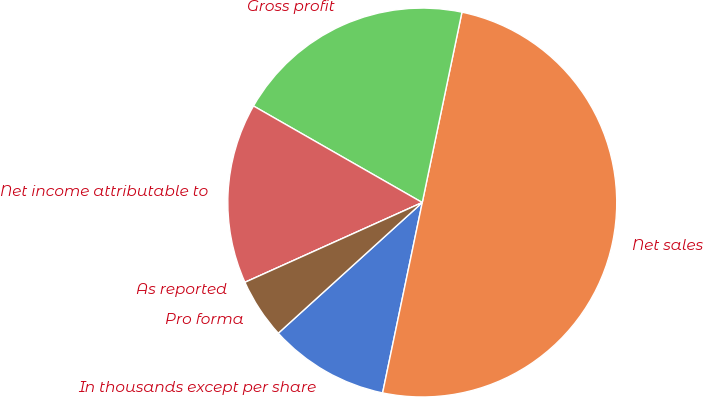Convert chart to OTSL. <chart><loc_0><loc_0><loc_500><loc_500><pie_chart><fcel>In thousands except per share<fcel>Net sales<fcel>Gross profit<fcel>Net income attributable to<fcel>As reported<fcel>Pro forma<nl><fcel>10.0%<fcel>50.0%<fcel>20.0%<fcel>15.0%<fcel>0.0%<fcel>5.0%<nl></chart> 